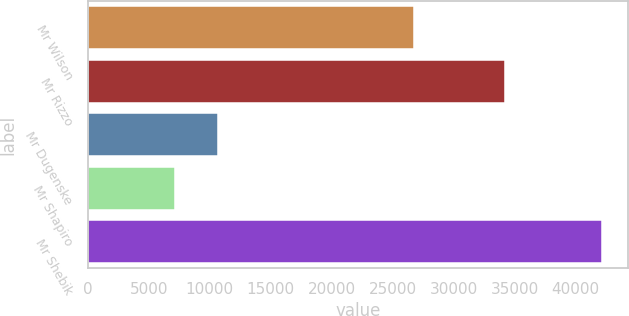Convert chart to OTSL. <chart><loc_0><loc_0><loc_500><loc_500><bar_chart><fcel>Mr Wilson<fcel>Mr Rizzo<fcel>Mr Dugenske<fcel>Mr Shapiro<fcel>Mr Shebik<nl><fcel>26769<fcel>34216<fcel>10679.9<fcel>7182<fcel>42161<nl></chart> 